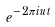<formula> <loc_0><loc_0><loc_500><loc_500>e ^ { - 2 \pi i u t }</formula> 